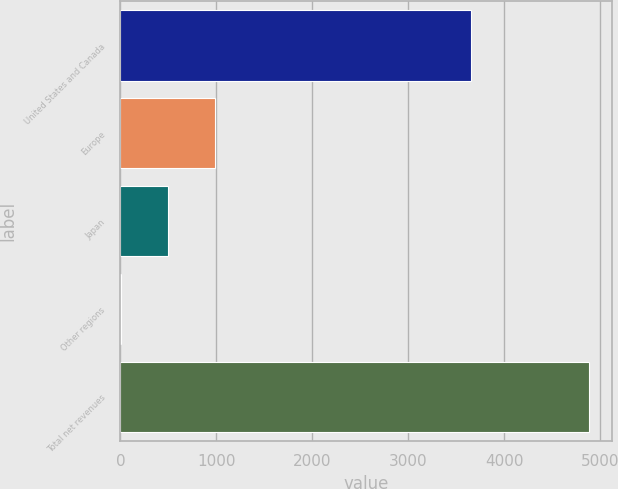<chart> <loc_0><loc_0><loc_500><loc_500><bar_chart><fcel>United States and Canada<fcel>Europe<fcel>Japan<fcel>Other regions<fcel>Total net revenues<nl><fcel>3653.1<fcel>983.94<fcel>496.92<fcel>9.9<fcel>4880.1<nl></chart> 